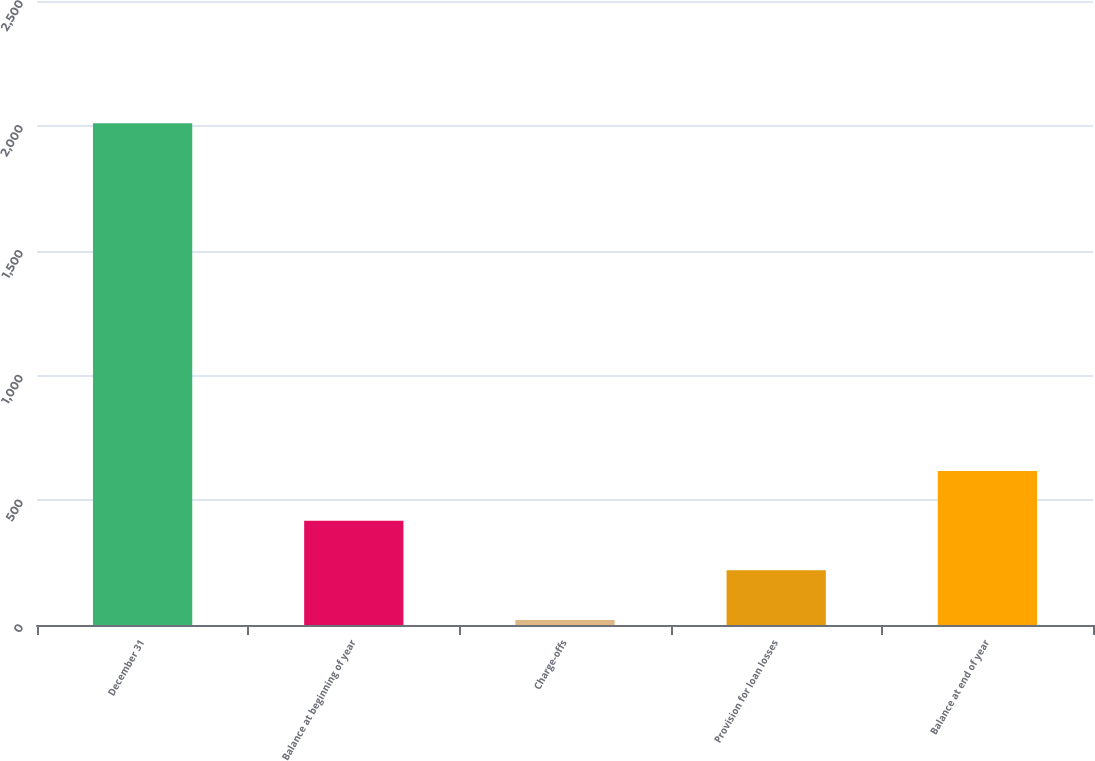<chart> <loc_0><loc_0><loc_500><loc_500><bar_chart><fcel>December 31<fcel>Balance at beginning of year<fcel>Charge-offs<fcel>Provision for loan losses<fcel>Balance at end of year<nl><fcel>2010<fcel>418<fcel>20<fcel>219<fcel>617<nl></chart> 